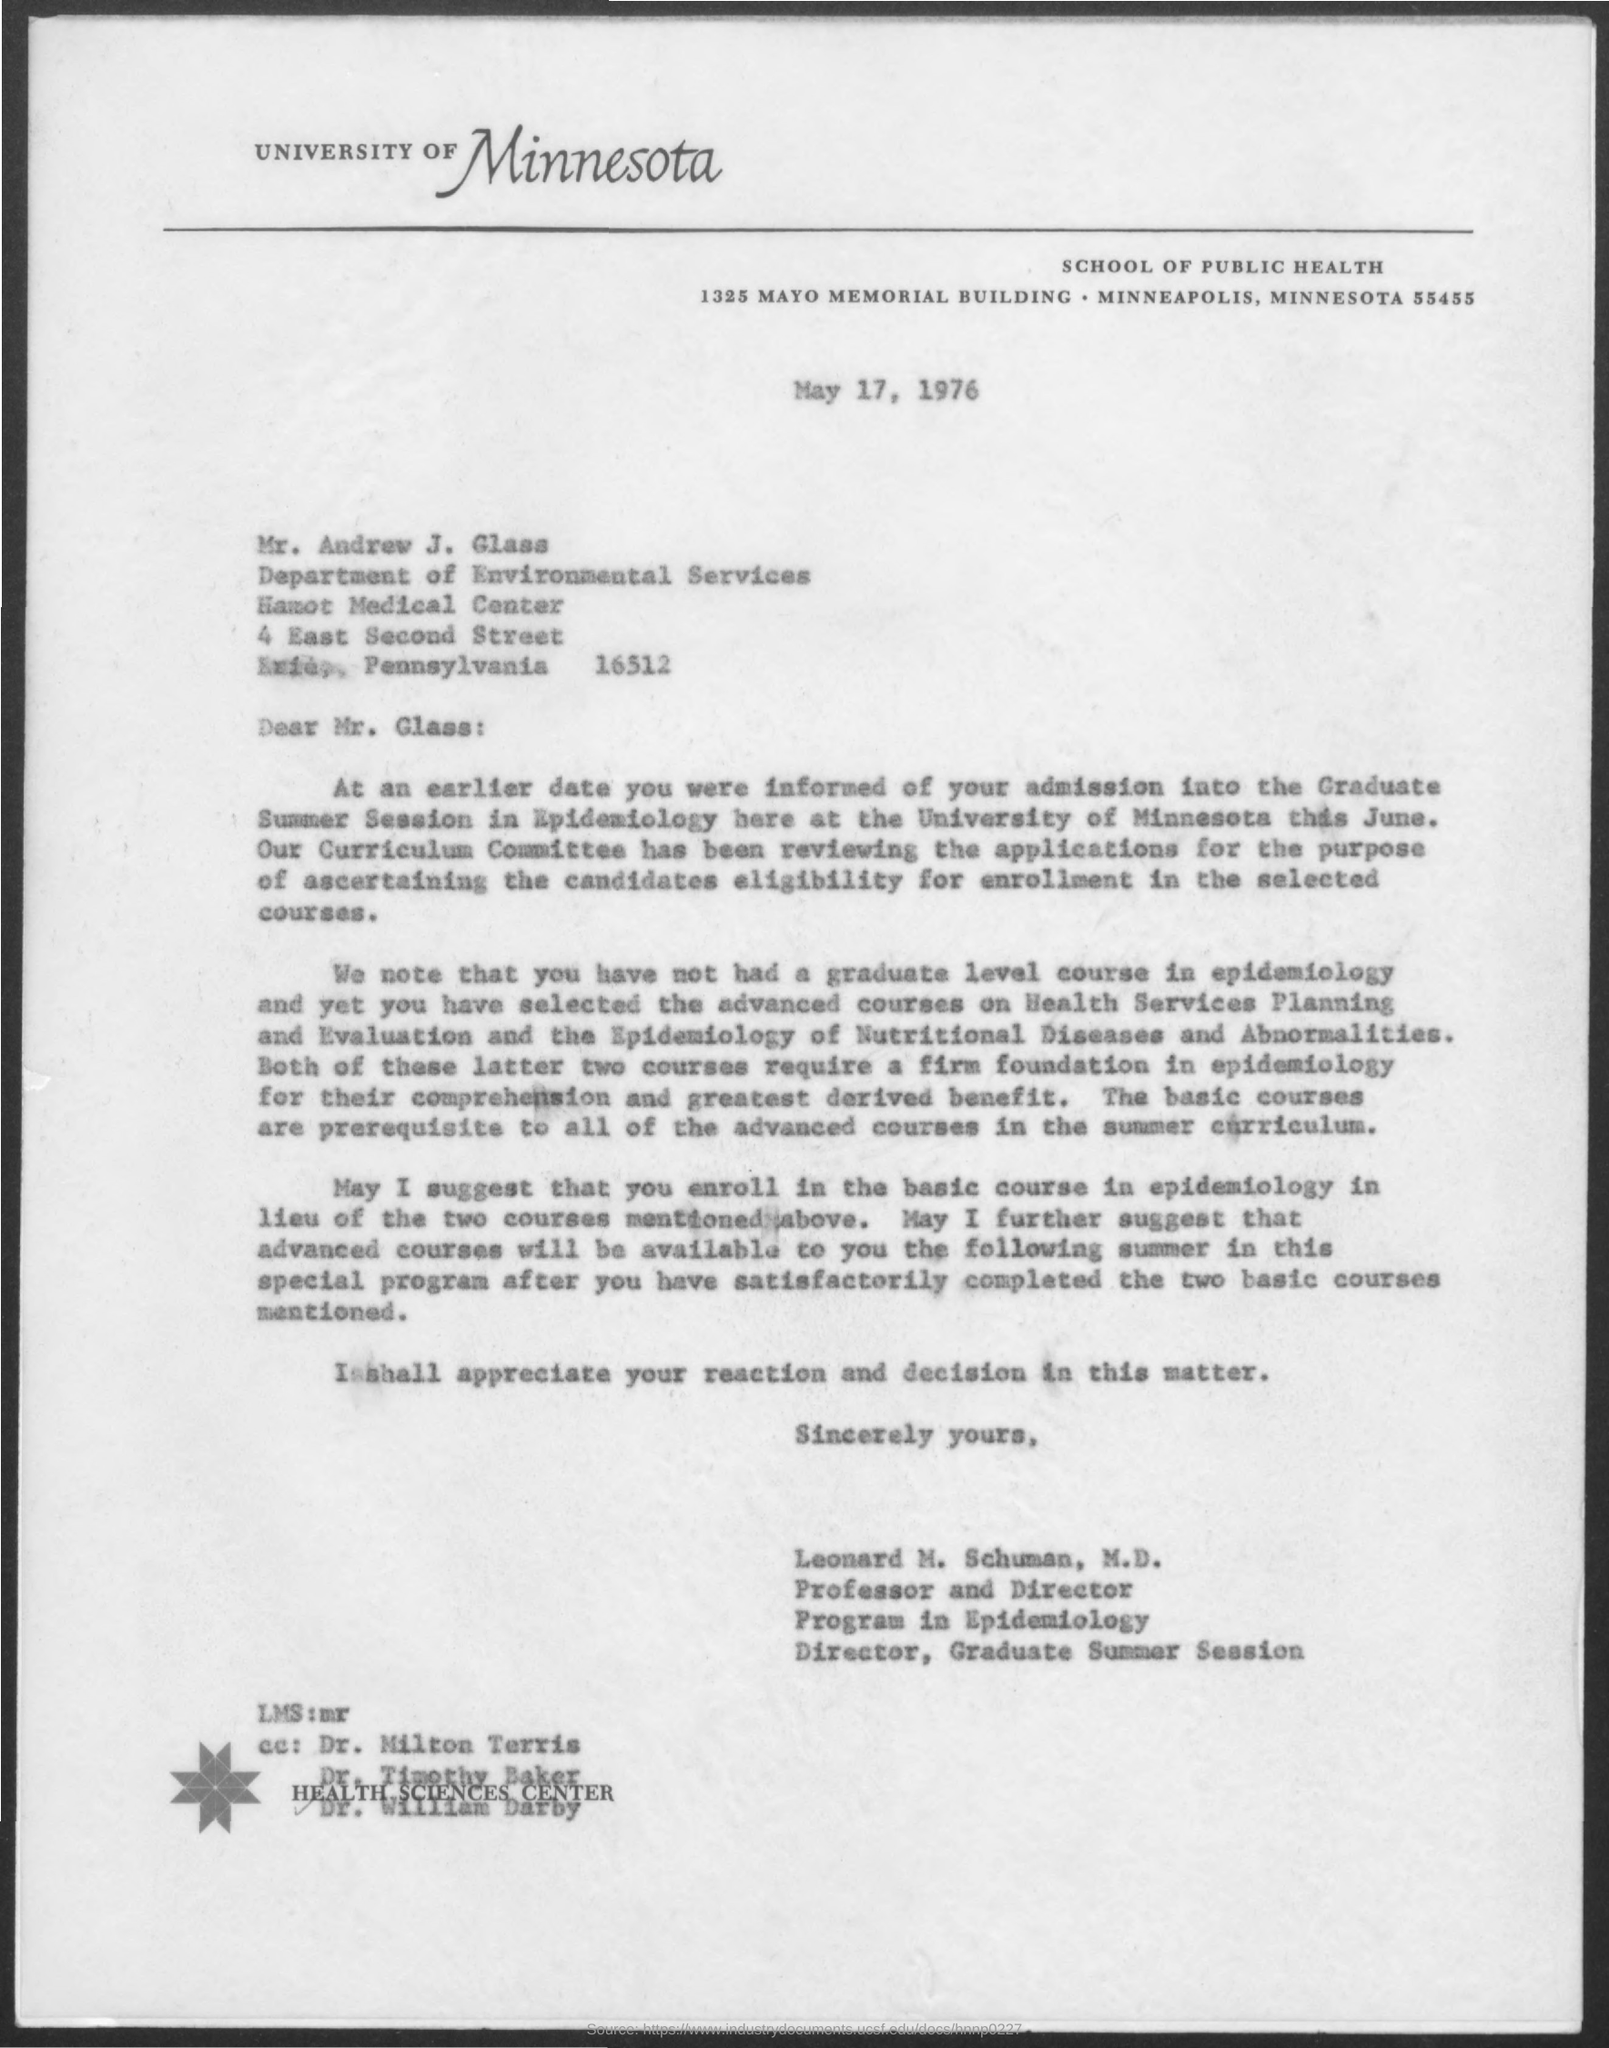When is the Memorandum dated on ?
Your answer should be compact. May 17, 1976. 